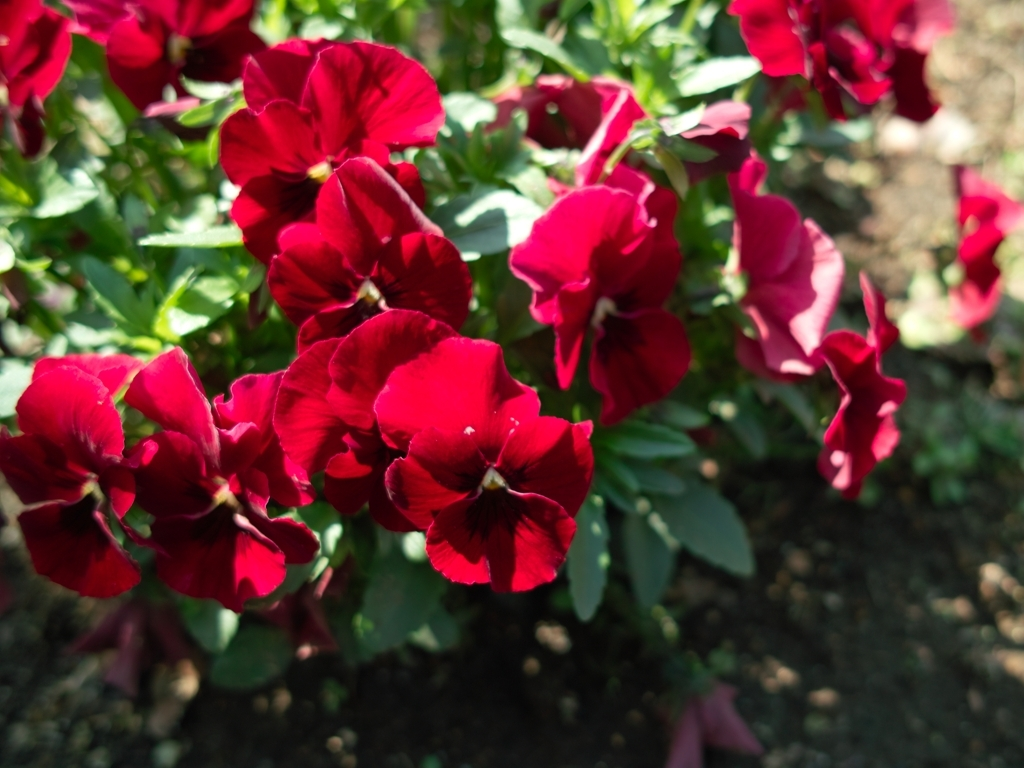What kind of flowers are depicted in this image? The image features a cluster of red flowers known as petunias, which are popular for their bright colors and are often found in gardens and floral displays. When is the best time to plant petunias? Petunias are best planted in the spring after the threat of frost has passed. They thrive in warm weather and should be placed in an area that receives full to partial sunlight. Do these flowers require any special care? Petunias are relatively low-maintenance. They require well-draining soil, regular watering to keep the soil moist, and occasional fertilization. Deadheading, or removing spent blooms, can encourage more flowers to grow. 